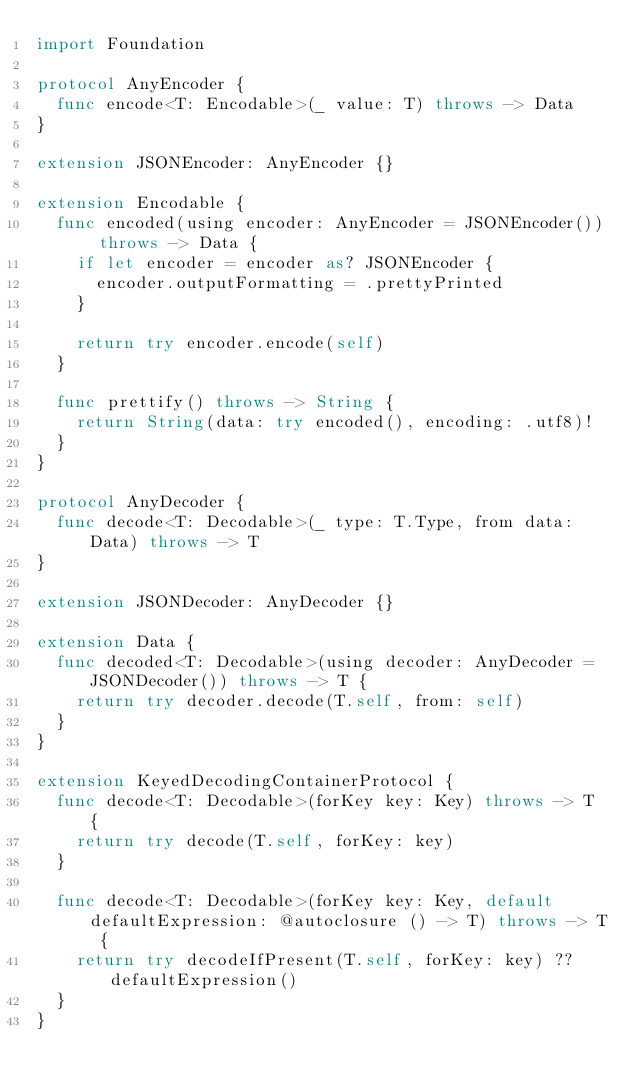<code> <loc_0><loc_0><loc_500><loc_500><_Swift_>import Foundation

protocol AnyEncoder {
  func encode<T: Encodable>(_ value: T) throws -> Data
}

extension JSONEncoder: AnyEncoder {}

extension Encodable {
  func encoded(using encoder: AnyEncoder = JSONEncoder()) throws -> Data {
    if let encoder = encoder as? JSONEncoder {
      encoder.outputFormatting = .prettyPrinted
    }

    return try encoder.encode(self)
  }

  func prettify() throws -> String {
    return String(data: try encoded(), encoding: .utf8)!
  }
}

protocol AnyDecoder {
  func decode<T: Decodable>(_ type: T.Type, from data: Data) throws -> T
}

extension JSONDecoder: AnyDecoder {}

extension Data {
  func decoded<T: Decodable>(using decoder: AnyDecoder = JSONDecoder()) throws -> T {
    return try decoder.decode(T.self, from: self)
  }
}

extension KeyedDecodingContainerProtocol {
  func decode<T: Decodable>(forKey key: Key) throws -> T {
    return try decode(T.self, forKey: key)
  }

  func decode<T: Decodable>(forKey key: Key, default defaultExpression: @autoclosure () -> T) throws -> T {
    return try decodeIfPresent(T.self, forKey: key) ?? defaultExpression()
  }
}


</code> 